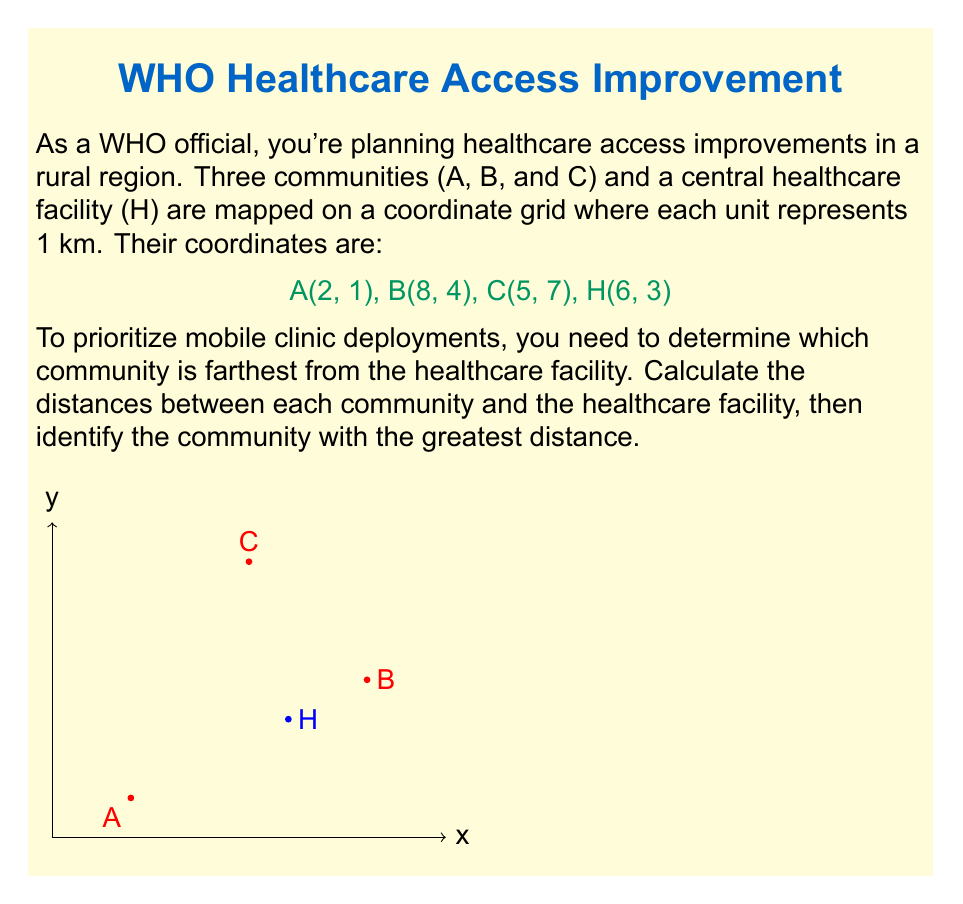What is the answer to this math problem? To solve this problem, we'll use the distance formula derived from the Pythagorean theorem:

$$ d = \sqrt{(x_2-x_1)^2 + (y_2-y_1)^2} $$

Where $(x_1,y_1)$ and $(x_2,y_2)$ are the coordinates of two points.

Step 1: Calculate the distance between A and H
$$ d_{AH} = \sqrt{(6-2)^2 + (3-1)^2} = \sqrt{4^2 + 2^2} = \sqrt{16 + 4} = \sqrt{20} \approx 4.47 \text{ km} $$

Step 2: Calculate the distance between B and H
$$ d_{BH} = \sqrt{(6-8)^2 + (3-4)^2} = \sqrt{(-2)^2 + (-1)^2} = \sqrt{4 + 1} = \sqrt{5} \approx 2.24 \text{ km} $$

Step 3: Calculate the distance between C and H
$$ d_{CH} = \sqrt{(6-5)^2 + (3-7)^2} = \sqrt{1^2 + (-4)^2} = \sqrt{1 + 16} = \sqrt{17} \approx 4.12 \text{ km} $$

Step 4: Compare the distances
A to H: 4.47 km
B to H: 2.24 km
C to H: 4.12 km

The greatest distance is between community A and the healthcare facility H.
Answer: Community A, 4.47 km from H 